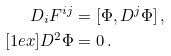<formula> <loc_0><loc_0><loc_500><loc_500>D _ { i } F ^ { i j } & = [ \Phi , D ^ { j } \Phi ] \, , \\ [ 1 e x ] D ^ { 2 } \Phi & = 0 \, .</formula> 